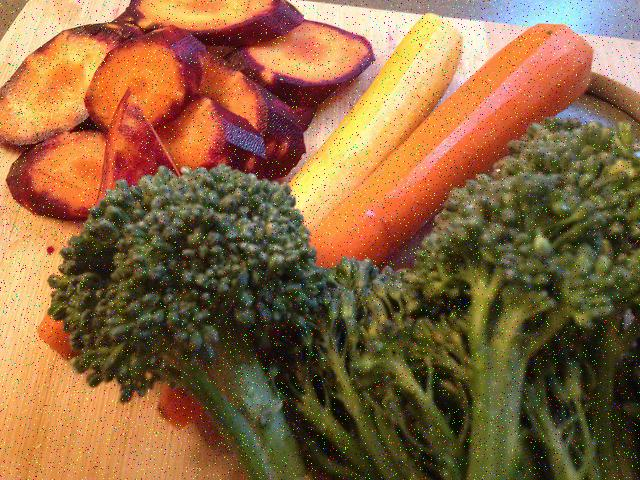Could this be a part of a specific diet or nutritional plan? Certainly! The image features vegetables often included in balanced diets due to their nutritional value. Broccoli is rich in vitamins K and C, fiber, and has anti-inflammatory properties. Carrots are known for being high in beta-carotene, fiber, vitamin K1, and antioxidants. Purple sweet potatoes are similarly fiber-rich and contain vitamins A and C. This mix could be part of a dietary plan focused on whole foods, which emphasize the consumption of minimally processed ingredients. 